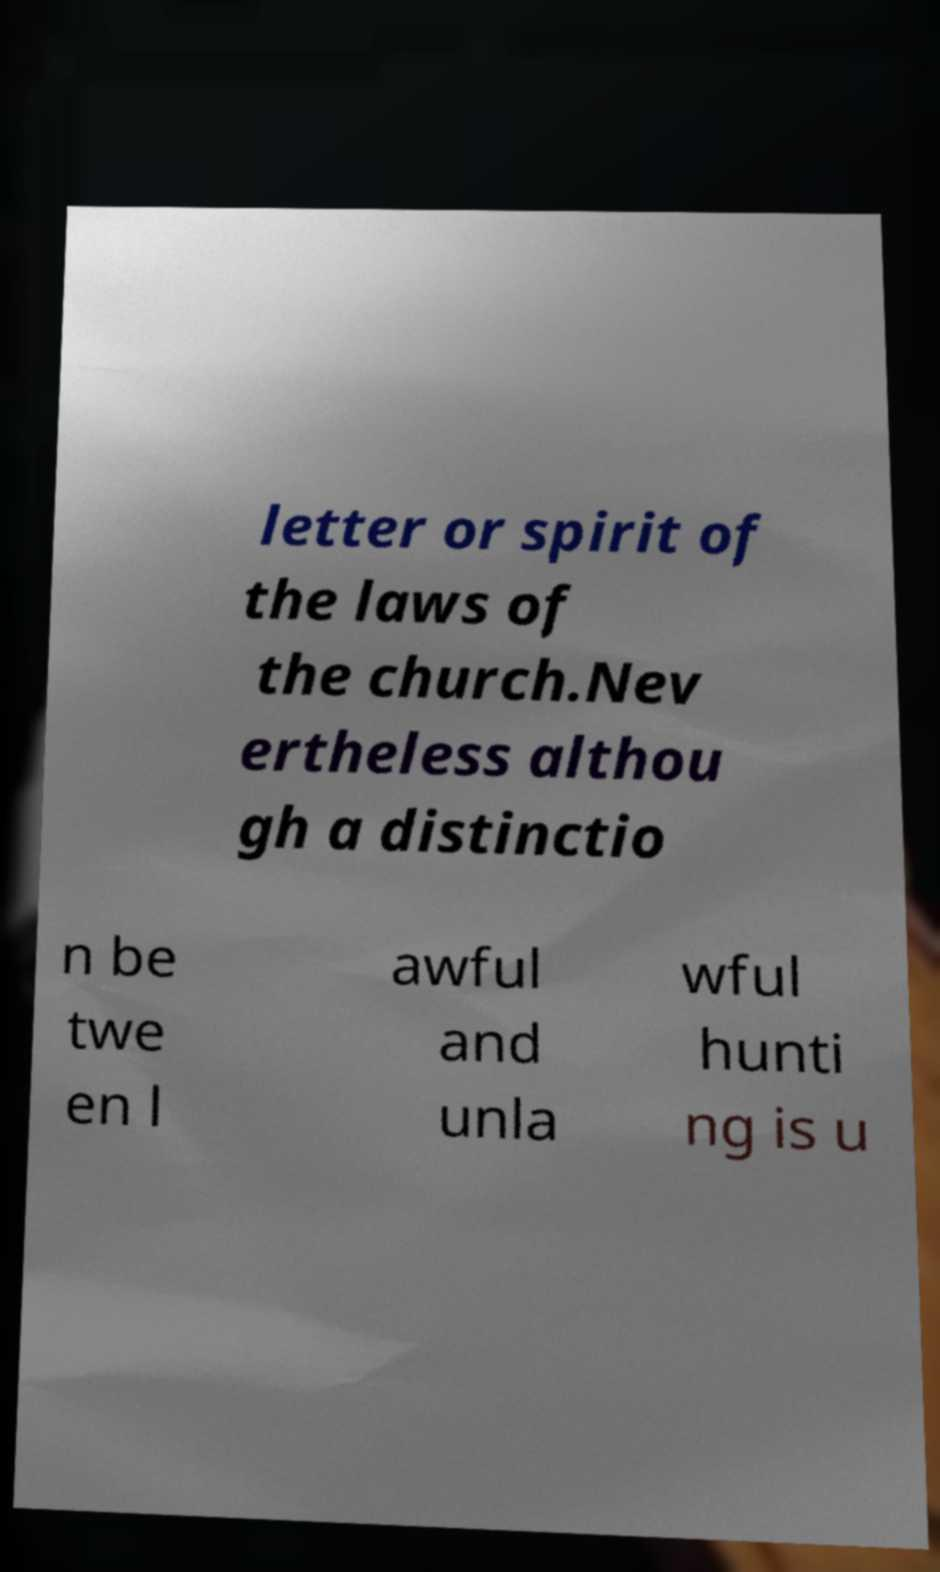Could you extract and type out the text from this image? letter or spirit of the laws of the church.Nev ertheless althou gh a distinctio n be twe en l awful and unla wful hunti ng is u 